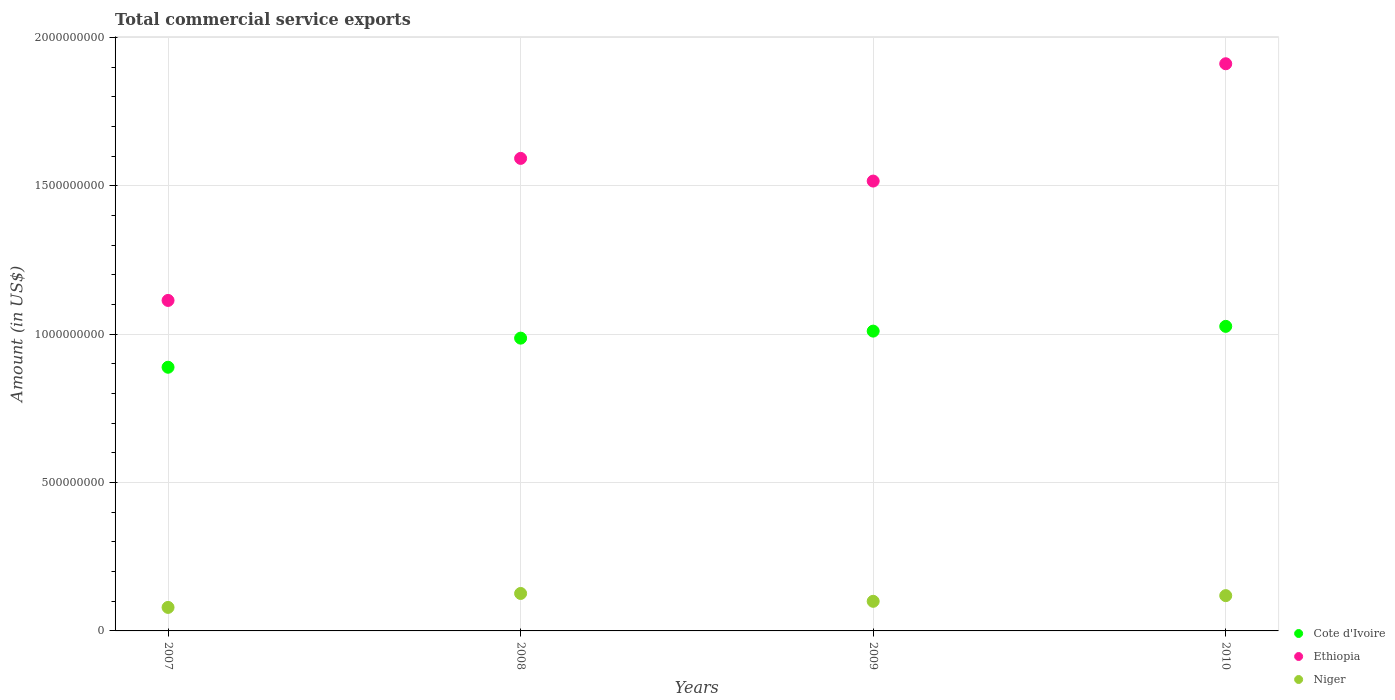How many different coloured dotlines are there?
Offer a very short reply. 3. Is the number of dotlines equal to the number of legend labels?
Offer a very short reply. Yes. What is the total commercial service exports in Niger in 2007?
Offer a terse response. 7.92e+07. Across all years, what is the maximum total commercial service exports in Cote d'Ivoire?
Your response must be concise. 1.03e+09. Across all years, what is the minimum total commercial service exports in Cote d'Ivoire?
Your answer should be very brief. 8.89e+08. What is the total total commercial service exports in Cote d'Ivoire in the graph?
Your answer should be compact. 3.91e+09. What is the difference between the total commercial service exports in Niger in 2008 and that in 2010?
Your response must be concise. 7.32e+06. What is the difference between the total commercial service exports in Niger in 2009 and the total commercial service exports in Ethiopia in 2010?
Your response must be concise. -1.81e+09. What is the average total commercial service exports in Niger per year?
Ensure brevity in your answer.  1.06e+08. In the year 2010, what is the difference between the total commercial service exports in Niger and total commercial service exports in Cote d'Ivoire?
Ensure brevity in your answer.  -9.07e+08. In how many years, is the total commercial service exports in Niger greater than 1100000000 US$?
Your answer should be compact. 0. What is the ratio of the total commercial service exports in Niger in 2007 to that in 2010?
Your answer should be compact. 0.67. What is the difference between the highest and the second highest total commercial service exports in Niger?
Your answer should be compact. 7.32e+06. What is the difference between the highest and the lowest total commercial service exports in Ethiopia?
Provide a short and direct response. 7.98e+08. In how many years, is the total commercial service exports in Niger greater than the average total commercial service exports in Niger taken over all years?
Provide a succinct answer. 2. Does the total commercial service exports in Niger monotonically increase over the years?
Your response must be concise. No. Is the total commercial service exports in Niger strictly greater than the total commercial service exports in Cote d'Ivoire over the years?
Keep it short and to the point. No. What is the difference between two consecutive major ticks on the Y-axis?
Make the answer very short. 5.00e+08. Are the values on the major ticks of Y-axis written in scientific E-notation?
Your response must be concise. No. Does the graph contain any zero values?
Provide a short and direct response. No. Does the graph contain grids?
Make the answer very short. Yes. Where does the legend appear in the graph?
Offer a terse response. Bottom right. What is the title of the graph?
Make the answer very short. Total commercial service exports. Does "Benin" appear as one of the legend labels in the graph?
Your response must be concise. No. What is the label or title of the X-axis?
Provide a short and direct response. Years. What is the label or title of the Y-axis?
Your answer should be very brief. Amount (in US$). What is the Amount (in US$) of Cote d'Ivoire in 2007?
Your response must be concise. 8.89e+08. What is the Amount (in US$) of Ethiopia in 2007?
Your answer should be compact. 1.11e+09. What is the Amount (in US$) of Niger in 2007?
Ensure brevity in your answer.  7.92e+07. What is the Amount (in US$) in Cote d'Ivoire in 2008?
Give a very brief answer. 9.87e+08. What is the Amount (in US$) in Ethiopia in 2008?
Provide a short and direct response. 1.59e+09. What is the Amount (in US$) in Niger in 2008?
Keep it short and to the point. 1.26e+08. What is the Amount (in US$) of Cote d'Ivoire in 2009?
Provide a succinct answer. 1.01e+09. What is the Amount (in US$) of Ethiopia in 2009?
Keep it short and to the point. 1.52e+09. What is the Amount (in US$) in Niger in 2009?
Provide a short and direct response. 9.98e+07. What is the Amount (in US$) in Cote d'Ivoire in 2010?
Provide a succinct answer. 1.03e+09. What is the Amount (in US$) in Ethiopia in 2010?
Your answer should be very brief. 1.91e+09. What is the Amount (in US$) in Niger in 2010?
Keep it short and to the point. 1.19e+08. Across all years, what is the maximum Amount (in US$) of Cote d'Ivoire?
Provide a short and direct response. 1.03e+09. Across all years, what is the maximum Amount (in US$) of Ethiopia?
Ensure brevity in your answer.  1.91e+09. Across all years, what is the maximum Amount (in US$) in Niger?
Provide a succinct answer. 1.26e+08. Across all years, what is the minimum Amount (in US$) of Cote d'Ivoire?
Your answer should be compact. 8.89e+08. Across all years, what is the minimum Amount (in US$) of Ethiopia?
Offer a terse response. 1.11e+09. Across all years, what is the minimum Amount (in US$) in Niger?
Offer a terse response. 7.92e+07. What is the total Amount (in US$) in Cote d'Ivoire in the graph?
Offer a terse response. 3.91e+09. What is the total Amount (in US$) of Ethiopia in the graph?
Your response must be concise. 6.13e+09. What is the total Amount (in US$) in Niger in the graph?
Provide a succinct answer. 4.24e+08. What is the difference between the Amount (in US$) in Cote d'Ivoire in 2007 and that in 2008?
Make the answer very short. -9.81e+07. What is the difference between the Amount (in US$) in Ethiopia in 2007 and that in 2008?
Your answer should be compact. -4.79e+08. What is the difference between the Amount (in US$) in Niger in 2007 and that in 2008?
Give a very brief answer. -4.70e+07. What is the difference between the Amount (in US$) of Cote d'Ivoire in 2007 and that in 2009?
Ensure brevity in your answer.  -1.22e+08. What is the difference between the Amount (in US$) in Ethiopia in 2007 and that in 2009?
Provide a short and direct response. -4.02e+08. What is the difference between the Amount (in US$) in Niger in 2007 and that in 2009?
Make the answer very short. -2.05e+07. What is the difference between the Amount (in US$) in Cote d'Ivoire in 2007 and that in 2010?
Offer a terse response. -1.38e+08. What is the difference between the Amount (in US$) in Ethiopia in 2007 and that in 2010?
Ensure brevity in your answer.  -7.98e+08. What is the difference between the Amount (in US$) of Niger in 2007 and that in 2010?
Your answer should be compact. -3.97e+07. What is the difference between the Amount (in US$) in Cote d'Ivoire in 2008 and that in 2009?
Offer a terse response. -2.37e+07. What is the difference between the Amount (in US$) of Ethiopia in 2008 and that in 2009?
Offer a terse response. 7.64e+07. What is the difference between the Amount (in US$) in Niger in 2008 and that in 2009?
Your answer should be very brief. 2.65e+07. What is the difference between the Amount (in US$) of Cote d'Ivoire in 2008 and that in 2010?
Your answer should be very brief. -3.97e+07. What is the difference between the Amount (in US$) in Ethiopia in 2008 and that in 2010?
Your response must be concise. -3.19e+08. What is the difference between the Amount (in US$) in Niger in 2008 and that in 2010?
Make the answer very short. 7.32e+06. What is the difference between the Amount (in US$) in Cote d'Ivoire in 2009 and that in 2010?
Offer a terse response. -1.60e+07. What is the difference between the Amount (in US$) in Ethiopia in 2009 and that in 2010?
Your answer should be very brief. -3.95e+08. What is the difference between the Amount (in US$) in Niger in 2009 and that in 2010?
Provide a succinct answer. -1.91e+07. What is the difference between the Amount (in US$) of Cote d'Ivoire in 2007 and the Amount (in US$) of Ethiopia in 2008?
Keep it short and to the point. -7.04e+08. What is the difference between the Amount (in US$) in Cote d'Ivoire in 2007 and the Amount (in US$) in Niger in 2008?
Provide a succinct answer. 7.62e+08. What is the difference between the Amount (in US$) in Ethiopia in 2007 and the Amount (in US$) in Niger in 2008?
Ensure brevity in your answer.  9.88e+08. What is the difference between the Amount (in US$) in Cote d'Ivoire in 2007 and the Amount (in US$) in Ethiopia in 2009?
Offer a very short reply. -6.27e+08. What is the difference between the Amount (in US$) in Cote d'Ivoire in 2007 and the Amount (in US$) in Niger in 2009?
Keep it short and to the point. 7.89e+08. What is the difference between the Amount (in US$) of Ethiopia in 2007 and the Amount (in US$) of Niger in 2009?
Ensure brevity in your answer.  1.01e+09. What is the difference between the Amount (in US$) of Cote d'Ivoire in 2007 and the Amount (in US$) of Ethiopia in 2010?
Ensure brevity in your answer.  -1.02e+09. What is the difference between the Amount (in US$) of Cote d'Ivoire in 2007 and the Amount (in US$) of Niger in 2010?
Make the answer very short. 7.70e+08. What is the difference between the Amount (in US$) of Ethiopia in 2007 and the Amount (in US$) of Niger in 2010?
Ensure brevity in your answer.  9.95e+08. What is the difference between the Amount (in US$) in Cote d'Ivoire in 2008 and the Amount (in US$) in Ethiopia in 2009?
Your response must be concise. -5.29e+08. What is the difference between the Amount (in US$) of Cote d'Ivoire in 2008 and the Amount (in US$) of Niger in 2009?
Provide a short and direct response. 8.87e+08. What is the difference between the Amount (in US$) of Ethiopia in 2008 and the Amount (in US$) of Niger in 2009?
Give a very brief answer. 1.49e+09. What is the difference between the Amount (in US$) of Cote d'Ivoire in 2008 and the Amount (in US$) of Ethiopia in 2010?
Offer a very short reply. -9.25e+08. What is the difference between the Amount (in US$) in Cote d'Ivoire in 2008 and the Amount (in US$) in Niger in 2010?
Make the answer very short. 8.68e+08. What is the difference between the Amount (in US$) of Ethiopia in 2008 and the Amount (in US$) of Niger in 2010?
Your answer should be compact. 1.47e+09. What is the difference between the Amount (in US$) in Cote d'Ivoire in 2009 and the Amount (in US$) in Ethiopia in 2010?
Ensure brevity in your answer.  -9.01e+08. What is the difference between the Amount (in US$) in Cote d'Ivoire in 2009 and the Amount (in US$) in Niger in 2010?
Your answer should be very brief. 8.91e+08. What is the difference between the Amount (in US$) in Ethiopia in 2009 and the Amount (in US$) in Niger in 2010?
Provide a short and direct response. 1.40e+09. What is the average Amount (in US$) in Cote d'Ivoire per year?
Your answer should be very brief. 9.78e+08. What is the average Amount (in US$) in Ethiopia per year?
Your response must be concise. 1.53e+09. What is the average Amount (in US$) in Niger per year?
Your response must be concise. 1.06e+08. In the year 2007, what is the difference between the Amount (in US$) in Cote d'Ivoire and Amount (in US$) in Ethiopia?
Give a very brief answer. -2.25e+08. In the year 2007, what is the difference between the Amount (in US$) in Cote d'Ivoire and Amount (in US$) in Niger?
Ensure brevity in your answer.  8.09e+08. In the year 2007, what is the difference between the Amount (in US$) of Ethiopia and Amount (in US$) of Niger?
Your answer should be very brief. 1.03e+09. In the year 2008, what is the difference between the Amount (in US$) in Cote d'Ivoire and Amount (in US$) in Ethiopia?
Give a very brief answer. -6.06e+08. In the year 2008, what is the difference between the Amount (in US$) in Cote d'Ivoire and Amount (in US$) in Niger?
Provide a succinct answer. 8.60e+08. In the year 2008, what is the difference between the Amount (in US$) in Ethiopia and Amount (in US$) in Niger?
Offer a very short reply. 1.47e+09. In the year 2009, what is the difference between the Amount (in US$) of Cote d'Ivoire and Amount (in US$) of Ethiopia?
Provide a short and direct response. -5.06e+08. In the year 2009, what is the difference between the Amount (in US$) of Cote d'Ivoire and Amount (in US$) of Niger?
Your answer should be compact. 9.11e+08. In the year 2009, what is the difference between the Amount (in US$) in Ethiopia and Amount (in US$) in Niger?
Keep it short and to the point. 1.42e+09. In the year 2010, what is the difference between the Amount (in US$) of Cote d'Ivoire and Amount (in US$) of Ethiopia?
Your answer should be very brief. -8.85e+08. In the year 2010, what is the difference between the Amount (in US$) of Cote d'Ivoire and Amount (in US$) of Niger?
Offer a terse response. 9.07e+08. In the year 2010, what is the difference between the Amount (in US$) of Ethiopia and Amount (in US$) of Niger?
Offer a very short reply. 1.79e+09. What is the ratio of the Amount (in US$) of Cote d'Ivoire in 2007 to that in 2008?
Offer a very short reply. 0.9. What is the ratio of the Amount (in US$) in Ethiopia in 2007 to that in 2008?
Your response must be concise. 0.7. What is the ratio of the Amount (in US$) in Niger in 2007 to that in 2008?
Give a very brief answer. 0.63. What is the ratio of the Amount (in US$) of Cote d'Ivoire in 2007 to that in 2009?
Your response must be concise. 0.88. What is the ratio of the Amount (in US$) of Ethiopia in 2007 to that in 2009?
Your answer should be very brief. 0.73. What is the ratio of the Amount (in US$) in Niger in 2007 to that in 2009?
Your answer should be compact. 0.79. What is the ratio of the Amount (in US$) of Cote d'Ivoire in 2007 to that in 2010?
Your answer should be very brief. 0.87. What is the ratio of the Amount (in US$) in Ethiopia in 2007 to that in 2010?
Offer a terse response. 0.58. What is the ratio of the Amount (in US$) of Niger in 2007 to that in 2010?
Make the answer very short. 0.67. What is the ratio of the Amount (in US$) of Cote d'Ivoire in 2008 to that in 2009?
Ensure brevity in your answer.  0.98. What is the ratio of the Amount (in US$) of Ethiopia in 2008 to that in 2009?
Keep it short and to the point. 1.05. What is the ratio of the Amount (in US$) in Niger in 2008 to that in 2009?
Your answer should be very brief. 1.27. What is the ratio of the Amount (in US$) in Cote d'Ivoire in 2008 to that in 2010?
Your answer should be compact. 0.96. What is the ratio of the Amount (in US$) in Ethiopia in 2008 to that in 2010?
Keep it short and to the point. 0.83. What is the ratio of the Amount (in US$) of Niger in 2008 to that in 2010?
Make the answer very short. 1.06. What is the ratio of the Amount (in US$) of Cote d'Ivoire in 2009 to that in 2010?
Ensure brevity in your answer.  0.98. What is the ratio of the Amount (in US$) of Ethiopia in 2009 to that in 2010?
Give a very brief answer. 0.79. What is the ratio of the Amount (in US$) in Niger in 2009 to that in 2010?
Provide a succinct answer. 0.84. What is the difference between the highest and the second highest Amount (in US$) in Cote d'Ivoire?
Your response must be concise. 1.60e+07. What is the difference between the highest and the second highest Amount (in US$) of Ethiopia?
Your answer should be very brief. 3.19e+08. What is the difference between the highest and the second highest Amount (in US$) of Niger?
Give a very brief answer. 7.32e+06. What is the difference between the highest and the lowest Amount (in US$) in Cote d'Ivoire?
Ensure brevity in your answer.  1.38e+08. What is the difference between the highest and the lowest Amount (in US$) of Ethiopia?
Give a very brief answer. 7.98e+08. What is the difference between the highest and the lowest Amount (in US$) of Niger?
Ensure brevity in your answer.  4.70e+07. 